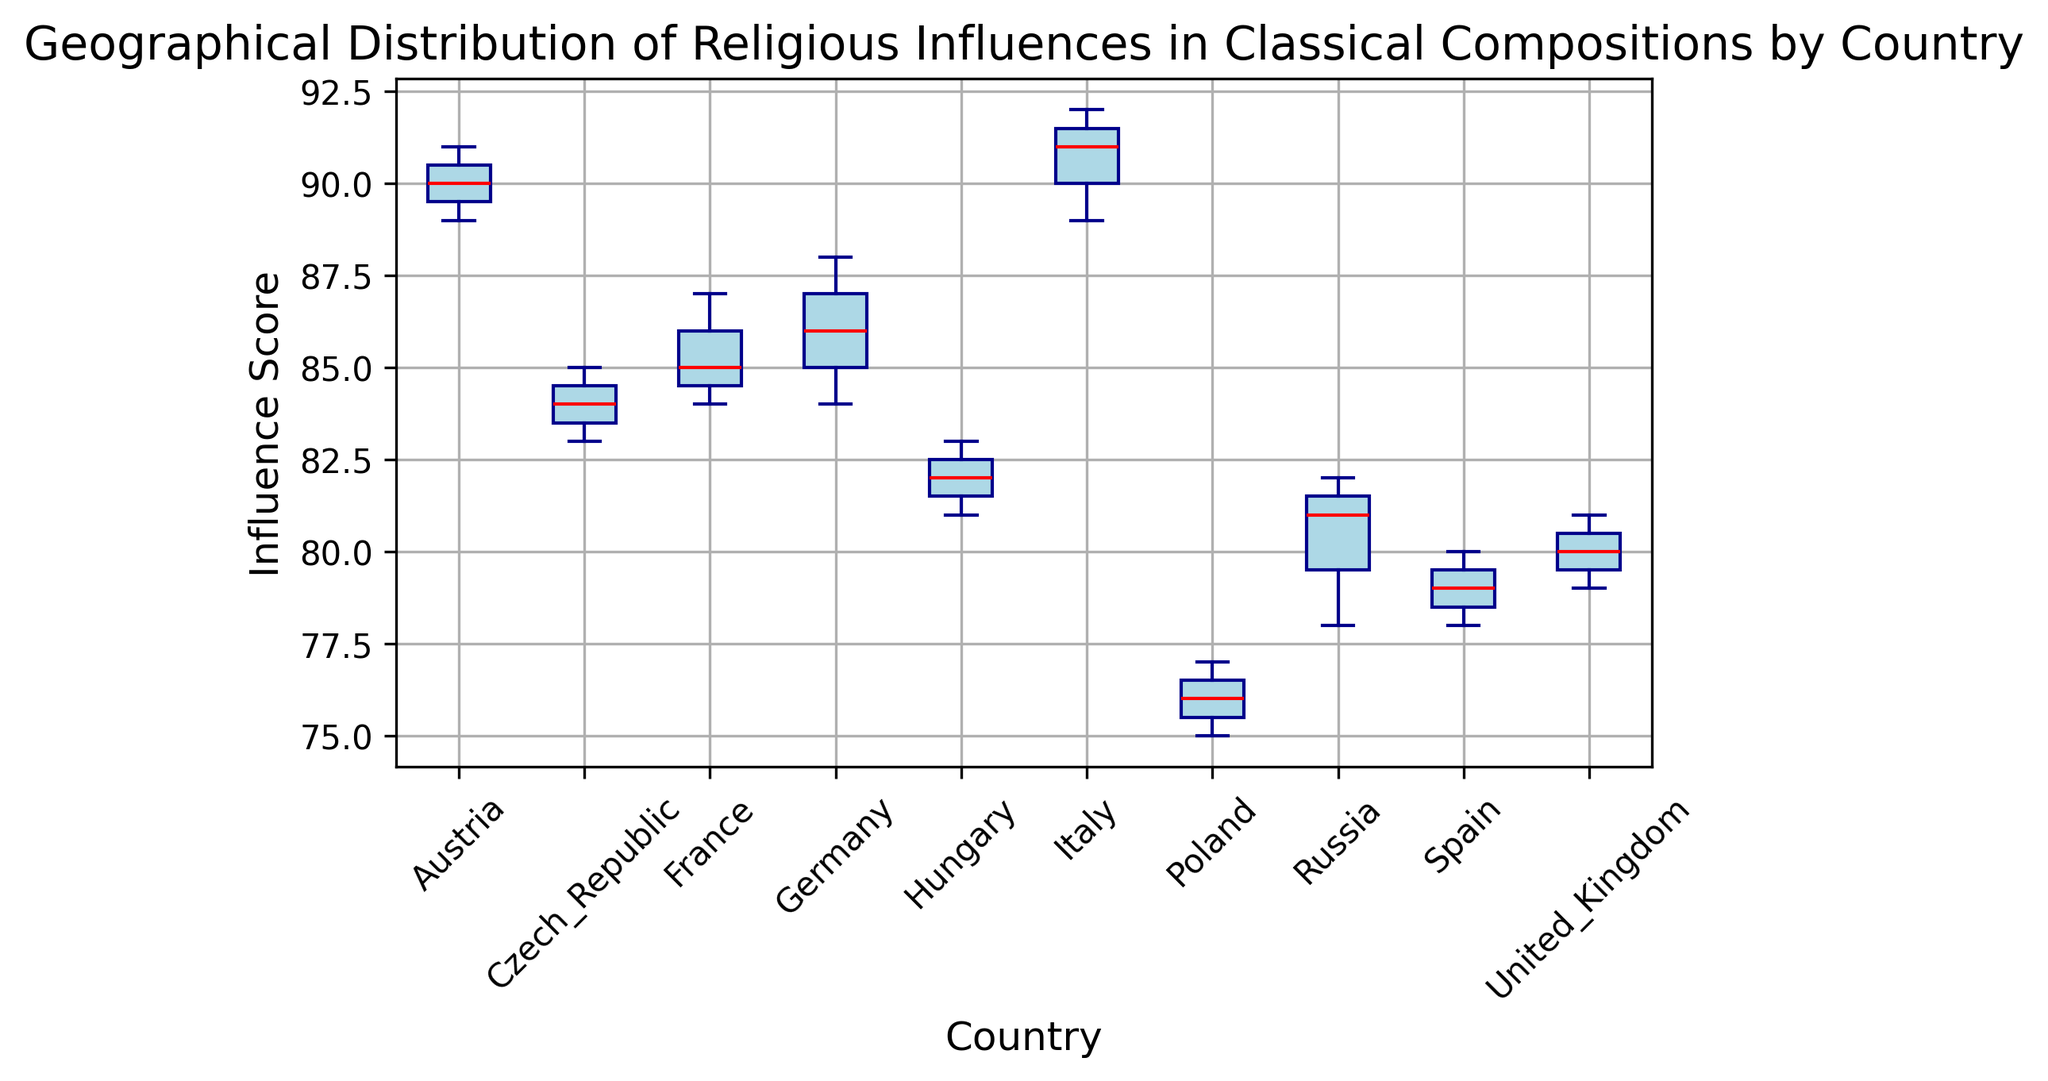Which country has the highest median Influence Score? To find the highest median Influence Score, look for the country with the red line at the highest position in the figure.
Answer: Italy Which country shows the widest range of Influence Scores? The range of Influence Scores is represented by the distance between the top and bottom whiskers. Identify the box with the longest vertical span.
Answer: Germany Which two countries have the same median Influence Score? Look for countries whose red median lines are at the same height.
Answer: France and Czech Republic What is the interquartile range (IQR) for Italy’s Influence Scores? The IQR is the difference between the upper and lower quartiles (the top and bottom of the box). Locate these positions and calculate the difference. Italy's upper quartile is 91, and lower quartile is 89.
Answer: 2 Are there any outliers in the Influence Scores for Russia? Outliers are individual points outside the whiskers. Check if there are any points plotted for Russia outside the whiskers.
Answer: Yes Which country has the smallest variation in Influence Scores? The smallest variation will have the shortest box and whiskers.
Answer: United Kingdom Compare the median Influence Scores of Austria and Hungary. Which is higher? Locate the red lines in the boxes for Austria and Hungary. Identify which is positioned higher.
Answer: Austria What is the Influence Score represented by the upper whisker for Spain? The upper whisker represents the highest regular data point not considered an outlier.
Answer: 80 Which countries have their boxes overlapping in terms of Influence Scores? Identify any boxes that span overlapping vertical ranges.
Answer: France and Czech Republic Between Poland and Spain, which has a higher lower quartile? Locate the bottom of the boxes for Poland and Spain, and see which is higher.
Answer: Spain 